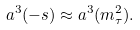Convert formula to latex. <formula><loc_0><loc_0><loc_500><loc_500>a ^ { 3 } ( - s ) \approx a ^ { 3 } ( m ^ { 2 } _ { \tau } ) .</formula> 